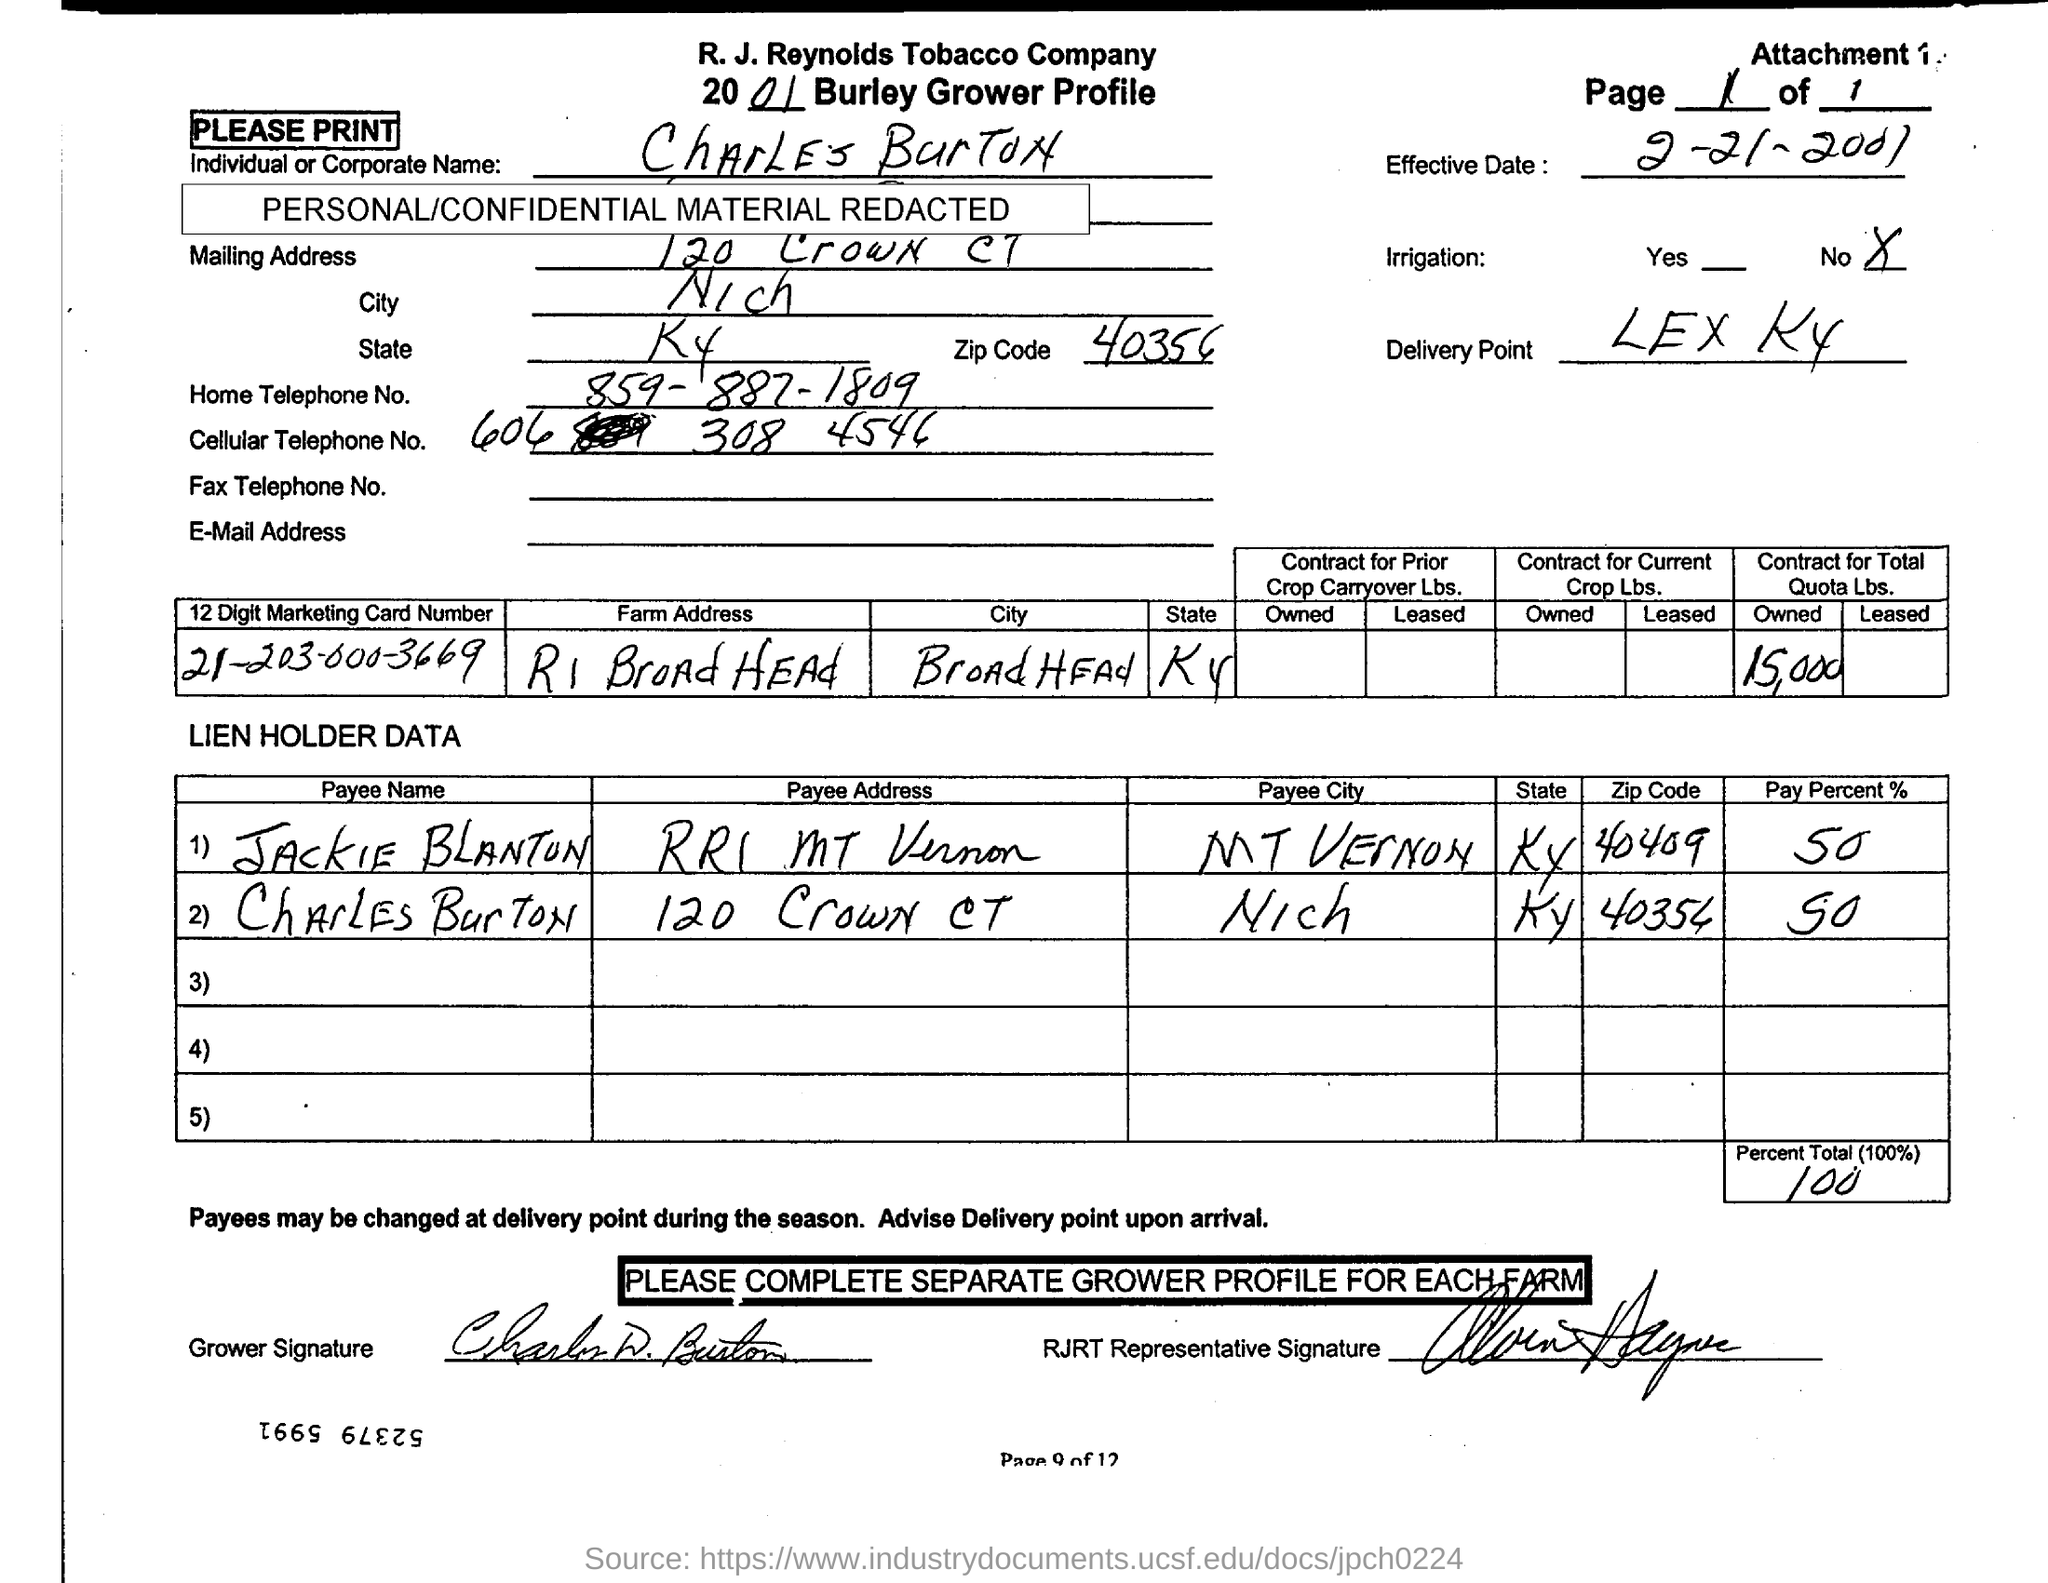Mention the owned  Quota Lbs. contract in total?
 15,000 